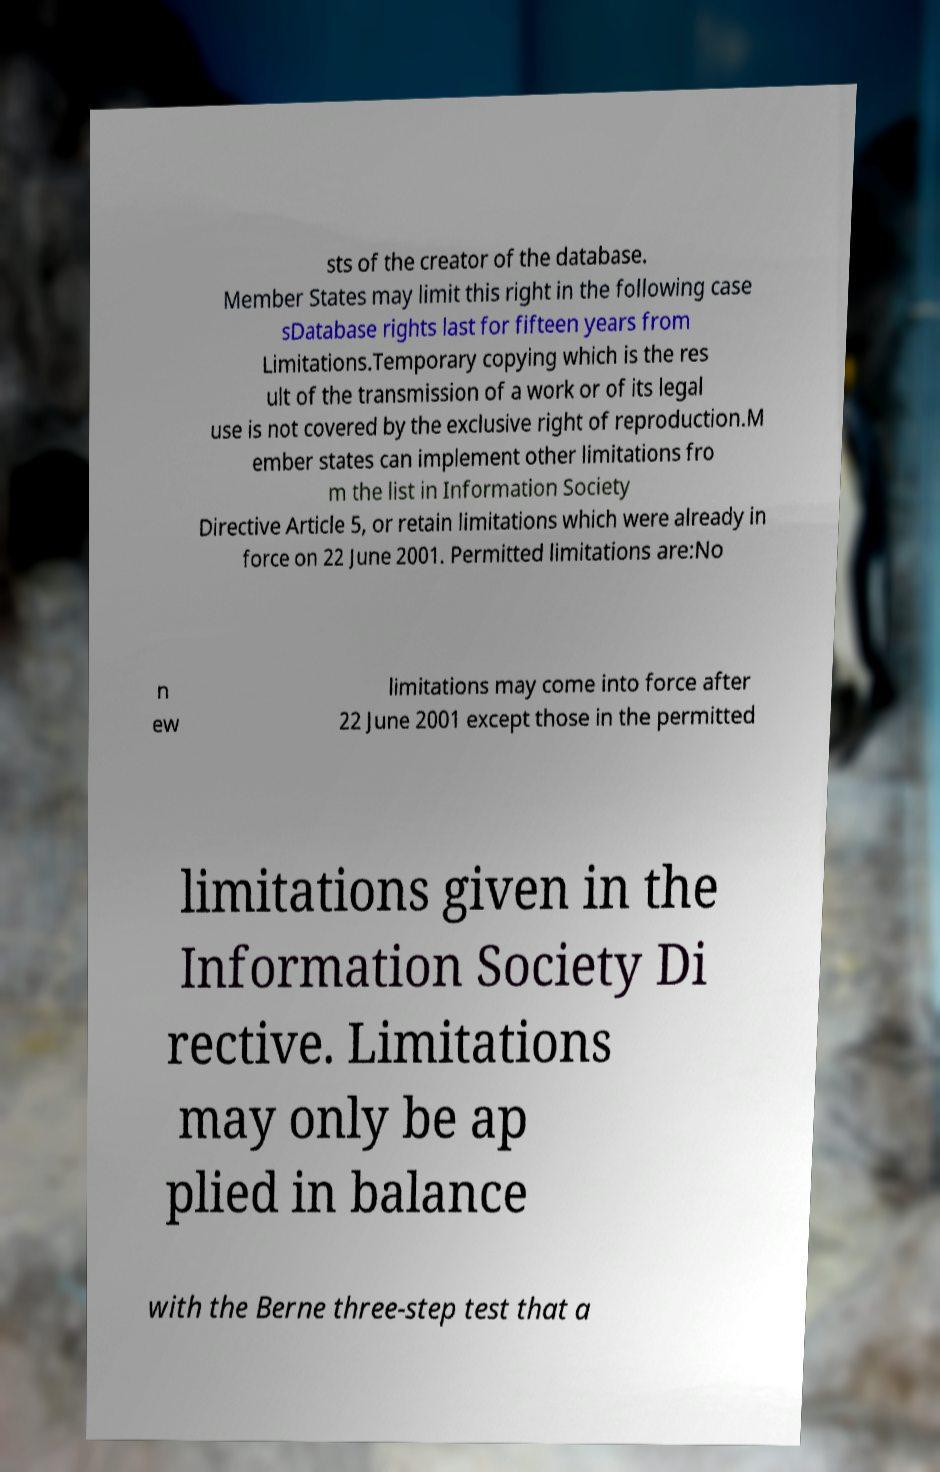For documentation purposes, I need the text within this image transcribed. Could you provide that? sts of the creator of the database. Member States may limit this right in the following case sDatabase rights last for fifteen years from Limitations.Temporary copying which is the res ult of the transmission of a work or of its legal use is not covered by the exclusive right of reproduction.M ember states can implement other limitations fro m the list in Information Society Directive Article 5, or retain limitations which were already in force on 22 June 2001. Permitted limitations are:No n ew limitations may come into force after 22 June 2001 except those in the permitted limitations given in the Information Society Di rective. Limitations may only be ap plied in balance with the Berne three-step test that a 